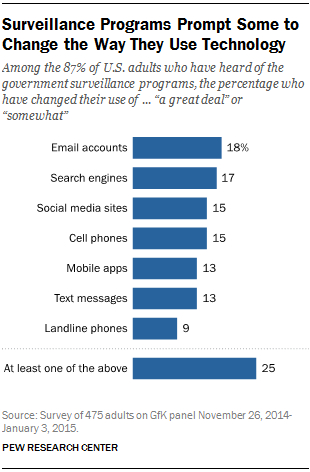Identify some key points in this picture. The chart shows the different ways in which the product is used by at least 15% of users. There are four ways in total that meet this criteria. According to a recent survey, the percentage value of cell phones is estimated to be around 15%. 